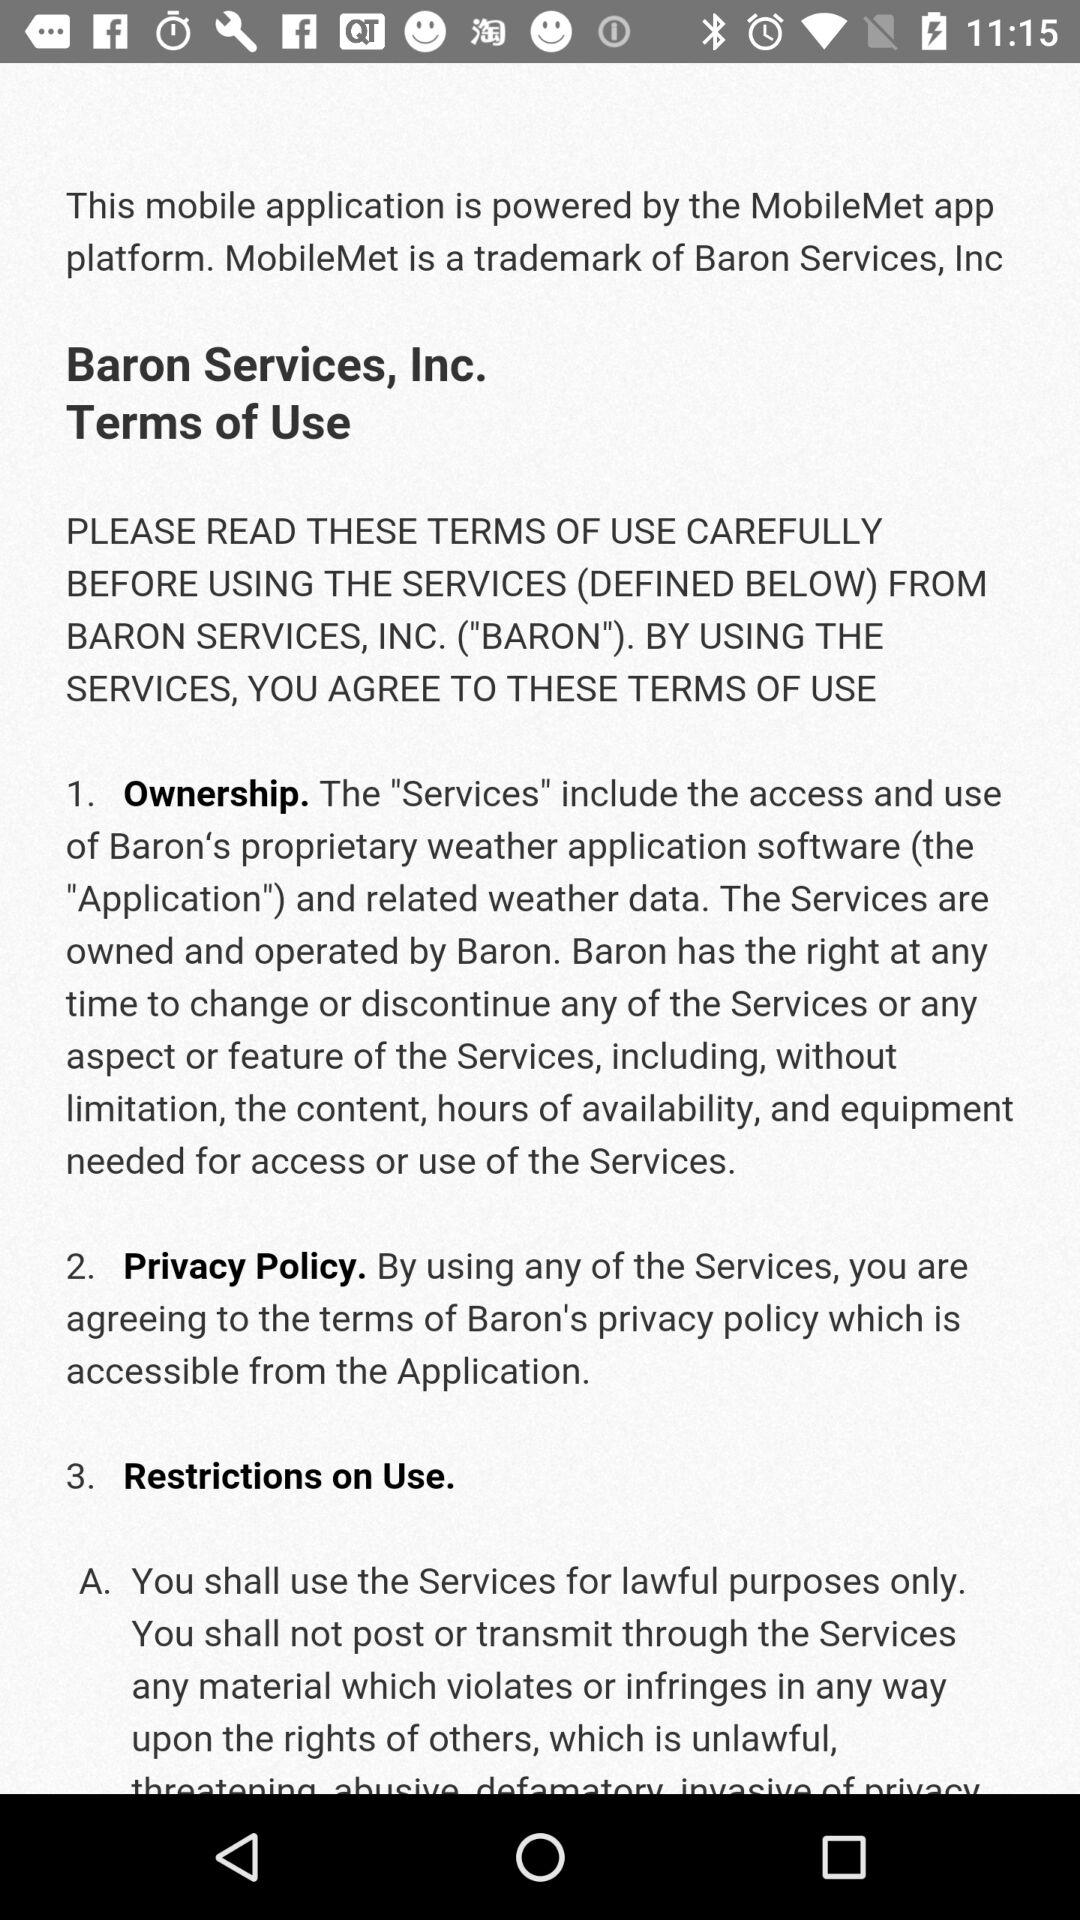What are the restrictions on use? The restrictions on use are: "You shall use the Services for lawful purposes only. You shall not post or transmit through the Services any material which violates or infringes in any way upon the rights of others, which is unlawful,". 